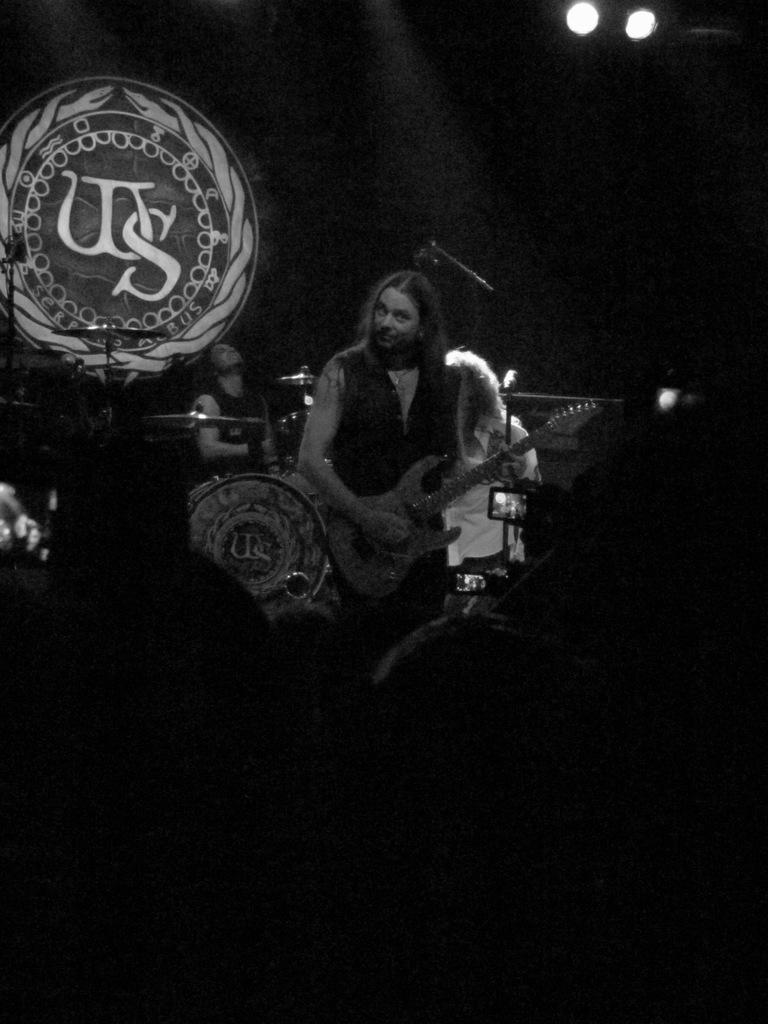What is the color scheme of the image? The image is black and white. How many people can be seen in the image? There are a few people in the image. What objects are related to music in the image? There are musical instruments and microphones in the image. What type of lighting is present in the image? There are lights in the image. Can you describe the wall in the image? There is a wall with a logo in the image. What is the reason the sisters are arguing about in the image? There are no sisters present in the image, nor is there any indication of an argument. 